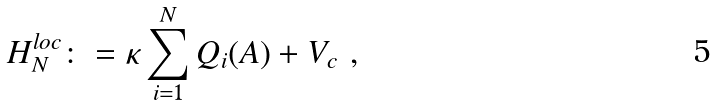<formula> <loc_0><loc_0><loc_500><loc_500>H ^ { l o c } _ { N } \colon = \kappa \sum _ { i = 1 } ^ { N } Q _ { i } ( A ) + V _ { c } \ ,</formula> 